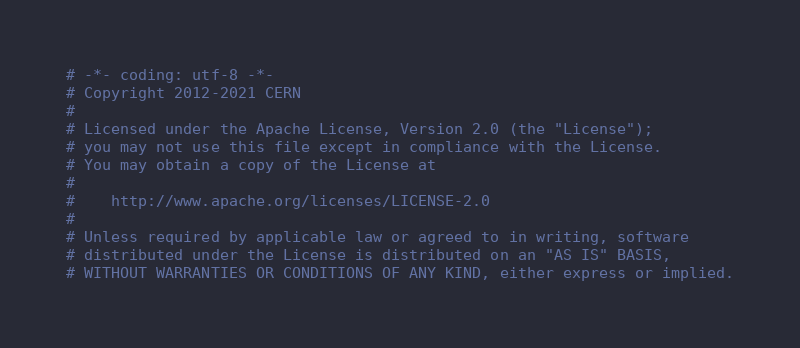<code> <loc_0><loc_0><loc_500><loc_500><_Python_># -*- coding: utf-8 -*-
# Copyright 2012-2021 CERN
#
# Licensed under the Apache License, Version 2.0 (the "License");
# you may not use this file except in compliance with the License.
# You may obtain a copy of the License at
#
#    http://www.apache.org/licenses/LICENSE-2.0
#
# Unless required by applicable law or agreed to in writing, software
# distributed under the License is distributed on an "AS IS" BASIS,
# WITHOUT WARRANTIES OR CONDITIONS OF ANY KIND, either express or implied.</code> 